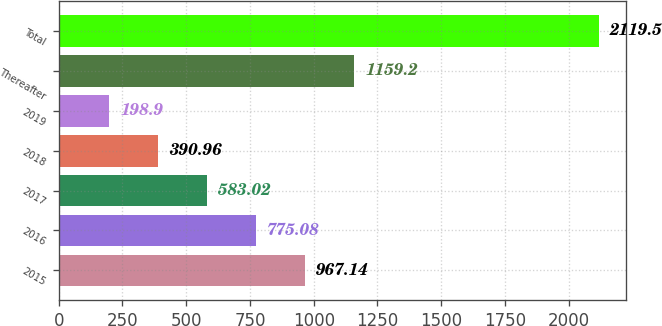Convert chart to OTSL. <chart><loc_0><loc_0><loc_500><loc_500><bar_chart><fcel>2015<fcel>2016<fcel>2017<fcel>2018<fcel>2019<fcel>Thereafter<fcel>Total<nl><fcel>967.14<fcel>775.08<fcel>583.02<fcel>390.96<fcel>198.9<fcel>1159.2<fcel>2119.5<nl></chart> 